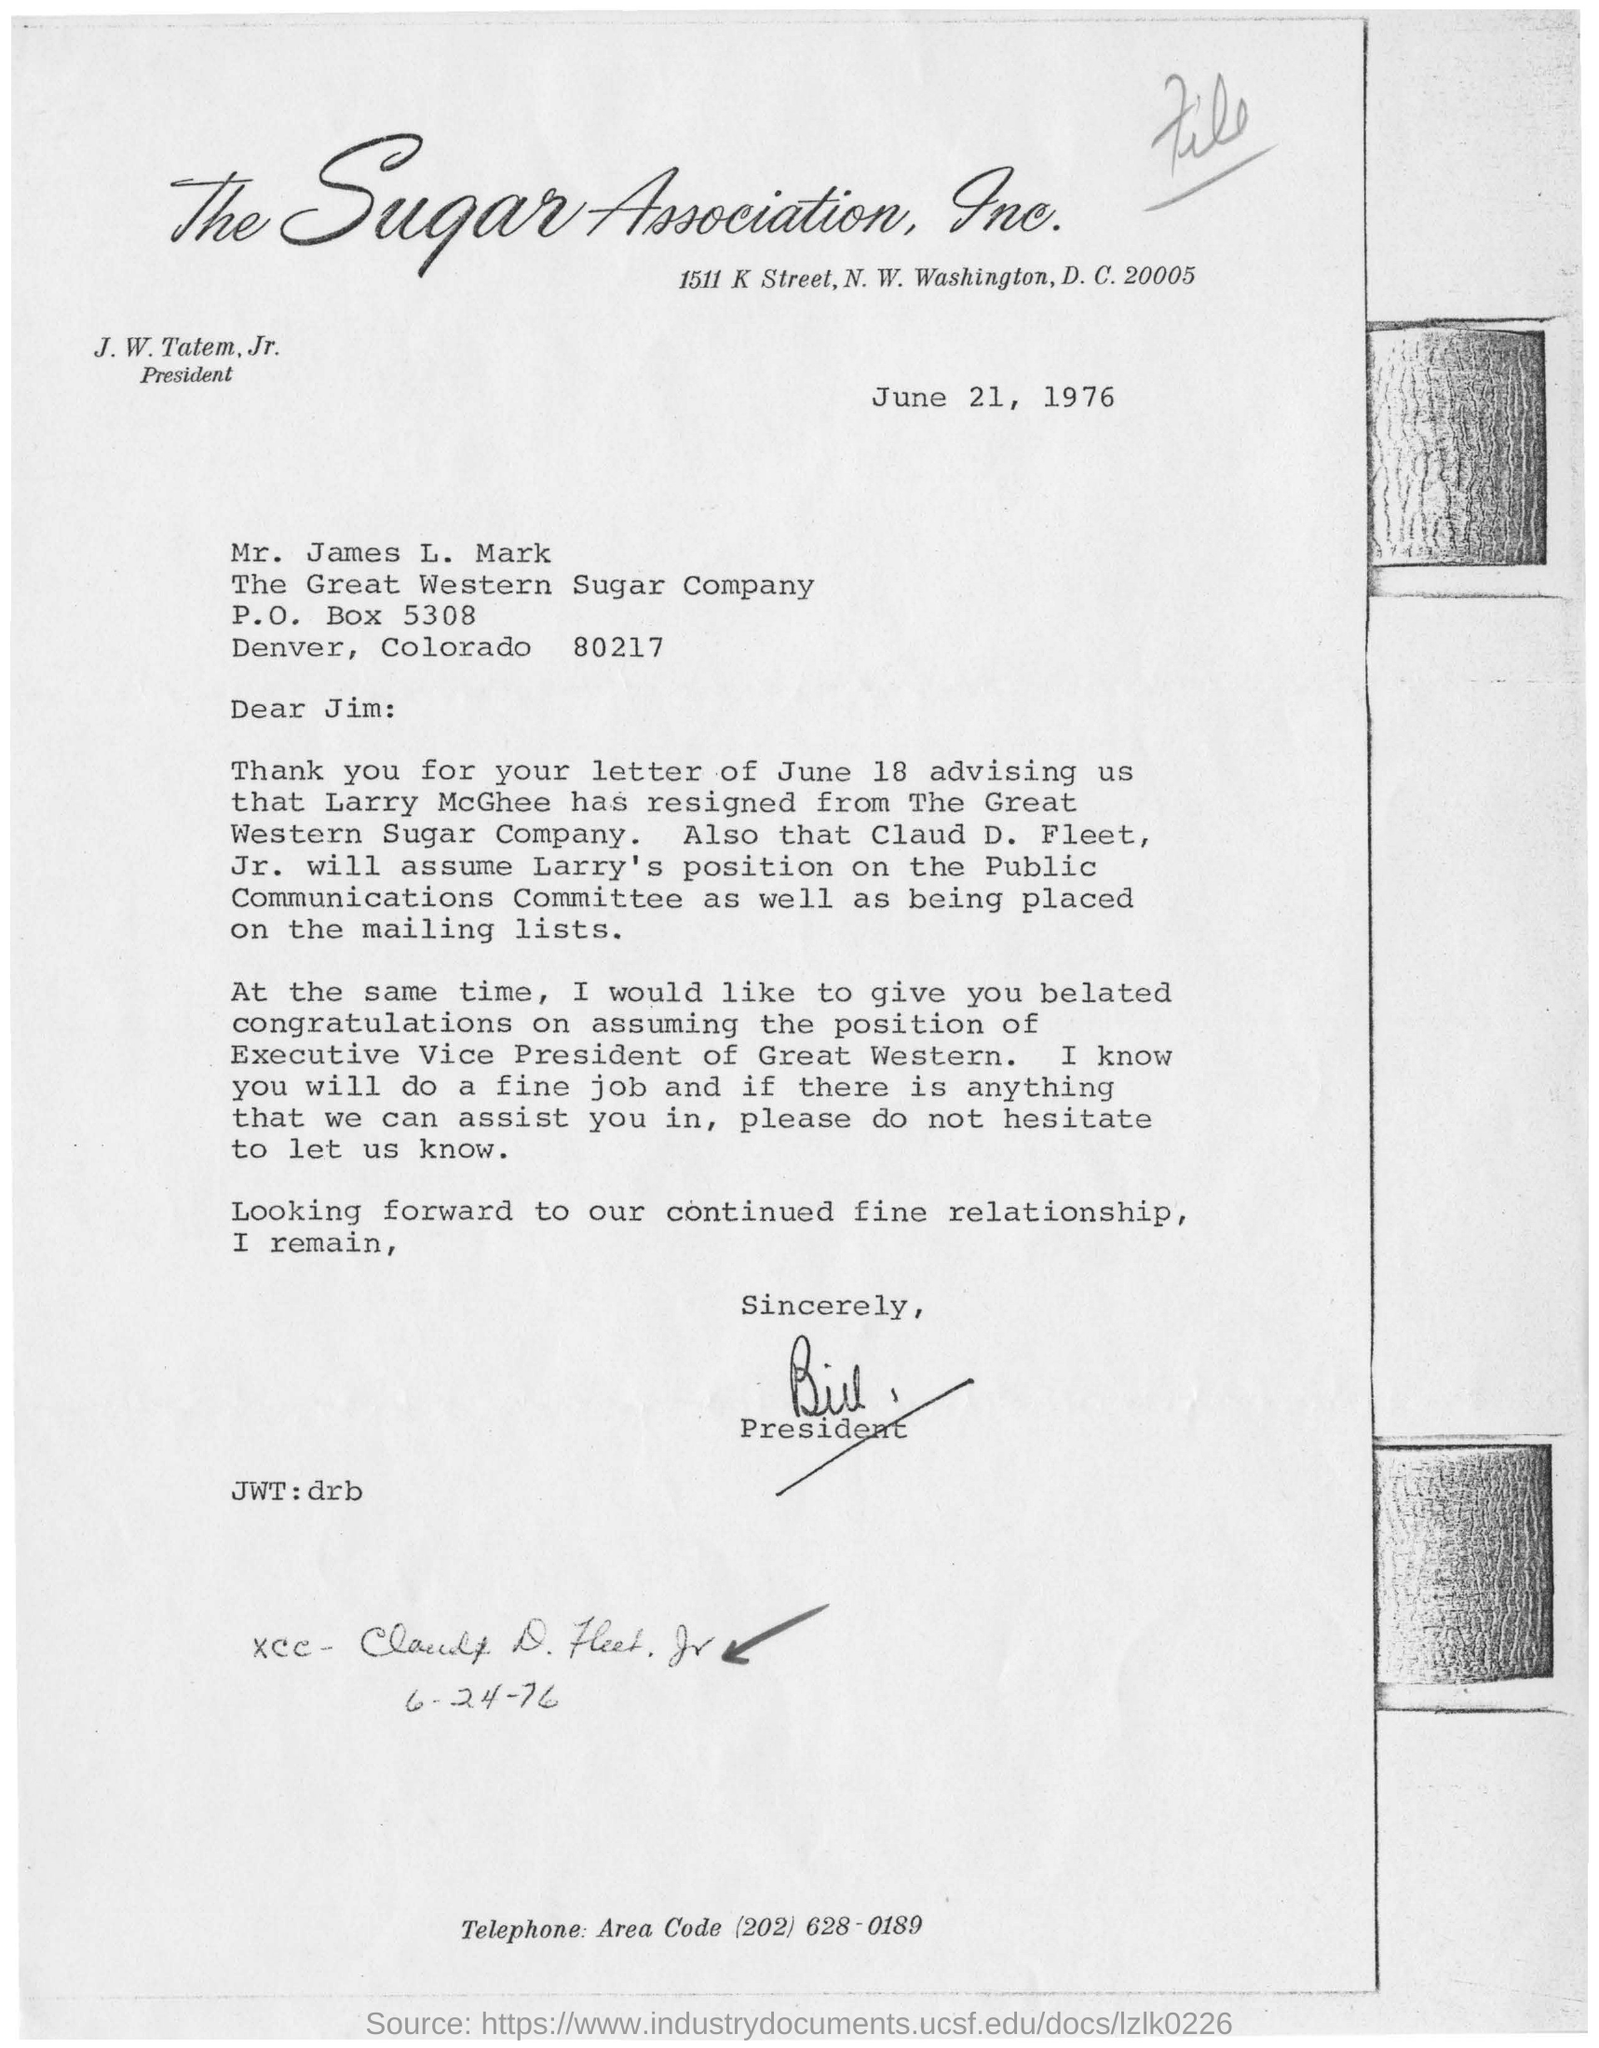Mention a couple of crucial points in this snapshot. The date mentioned above is June 21, 1976. 